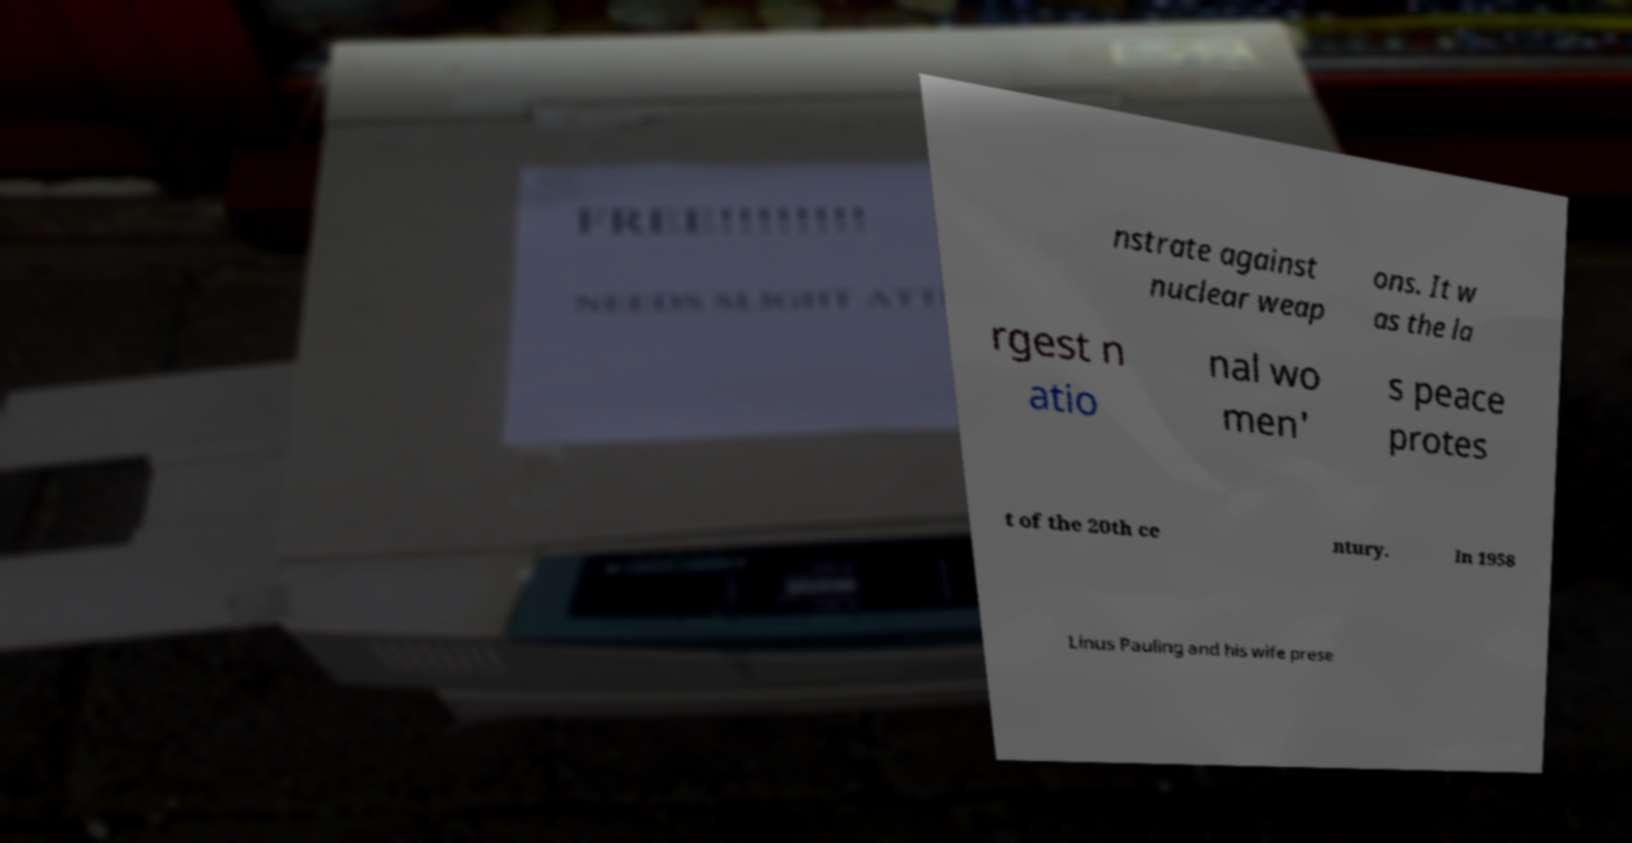Please identify and transcribe the text found in this image. nstrate against nuclear weap ons. It w as the la rgest n atio nal wo men' s peace protes t of the 20th ce ntury. In 1958 Linus Pauling and his wife prese 